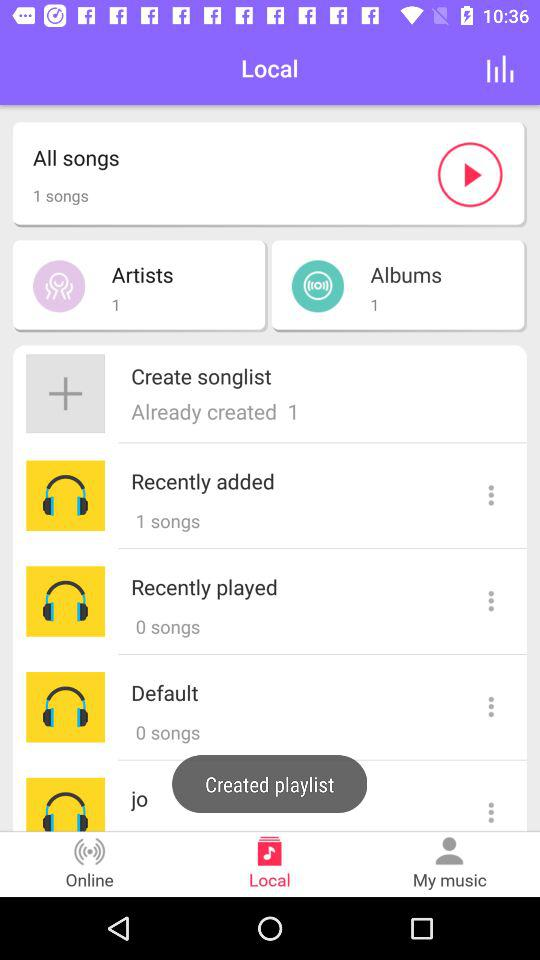How many "Recently played" songs are there? There are 0 songs. 